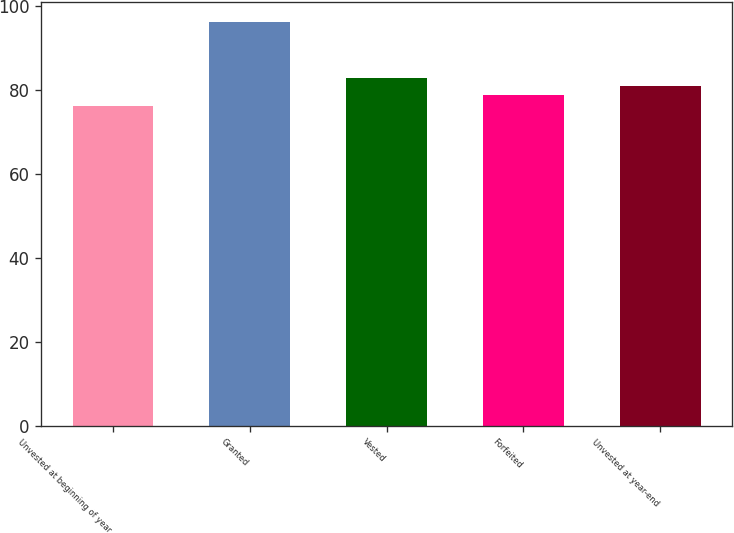Convert chart to OTSL. <chart><loc_0><loc_0><loc_500><loc_500><bar_chart><fcel>Unvested at beginning of year<fcel>Granted<fcel>Vested<fcel>Forfeited<fcel>Unvested at year-end<nl><fcel>76.01<fcel>96.08<fcel>82.81<fcel>78.68<fcel>80.8<nl></chart> 